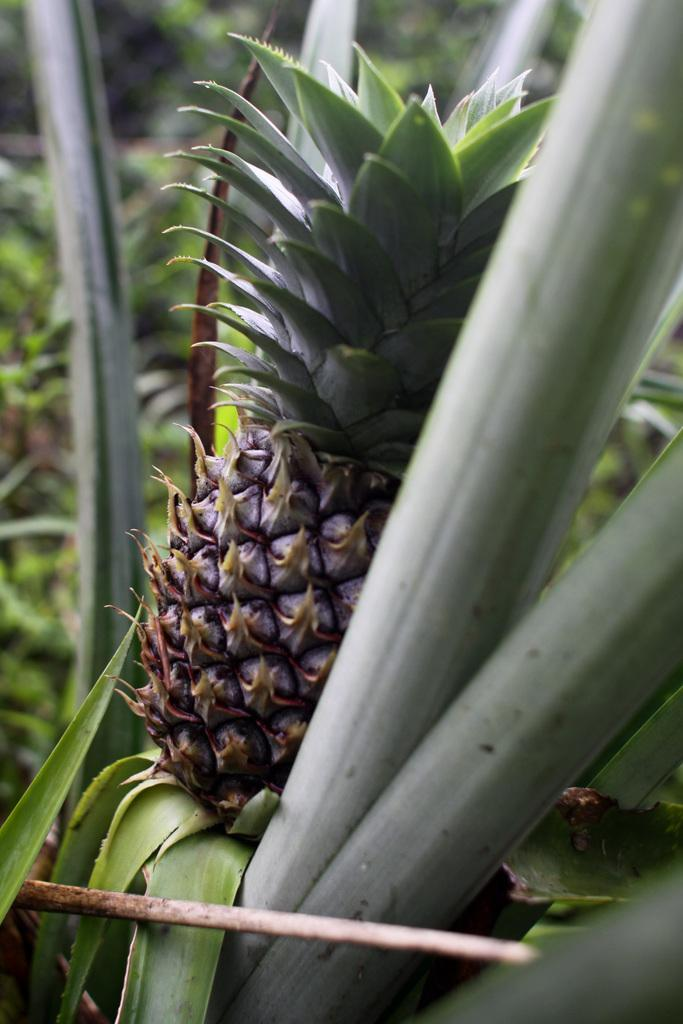What fruit can be seen on a tree in the image? There is a pineapple on a tree in the image. What else can be seen in the image besides the pineapple? There are trees visible behind the tree with the pineapple. What type of learning is taking place in the image? There is no learning activity depicted in the image; it shows a pineapple on a tree and other trees in the background. 